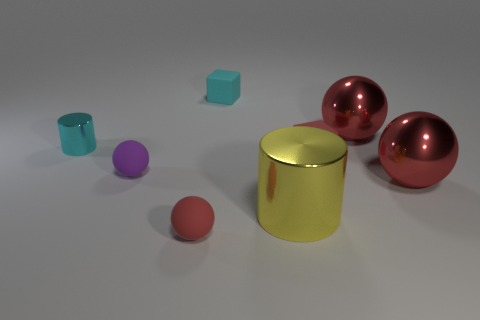What is the relative size of the purple object compared to the larger red spheres? The purple object is significantly smaller when compared to the large red spheres. It appears to be about one-fourth the diameter of the spheres. 